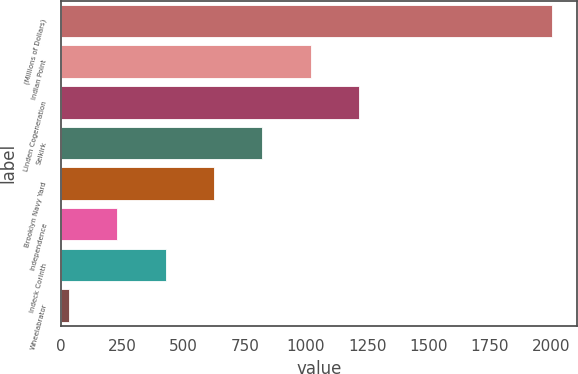<chart> <loc_0><loc_0><loc_500><loc_500><bar_chart><fcel>(Millions of Dollars)<fcel>Indian Point<fcel>Linden Cogeneration<fcel>Selkirk<fcel>Brooklyn Navy Yard<fcel>Independence<fcel>Indeck Corinth<fcel>Wheelabrator<nl><fcel>2005<fcel>1018.5<fcel>1215.8<fcel>821.2<fcel>623.9<fcel>229.3<fcel>426.6<fcel>32<nl></chart> 